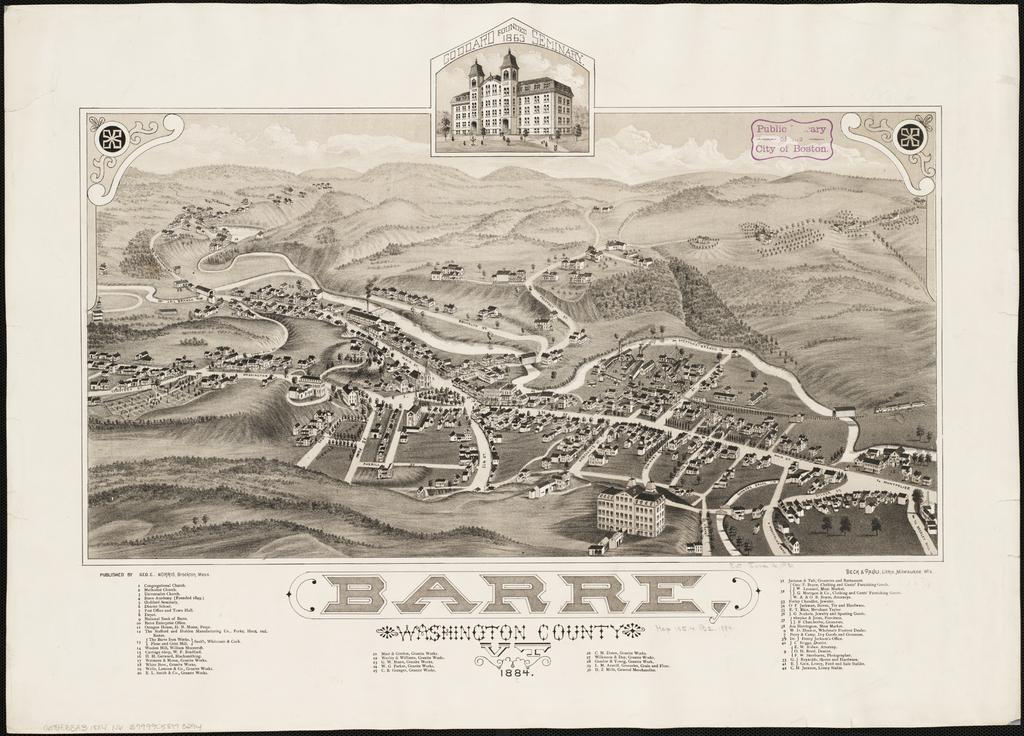<image>
Share a concise interpretation of the image provided. An 1884 drawing of Barre in Washington County. 